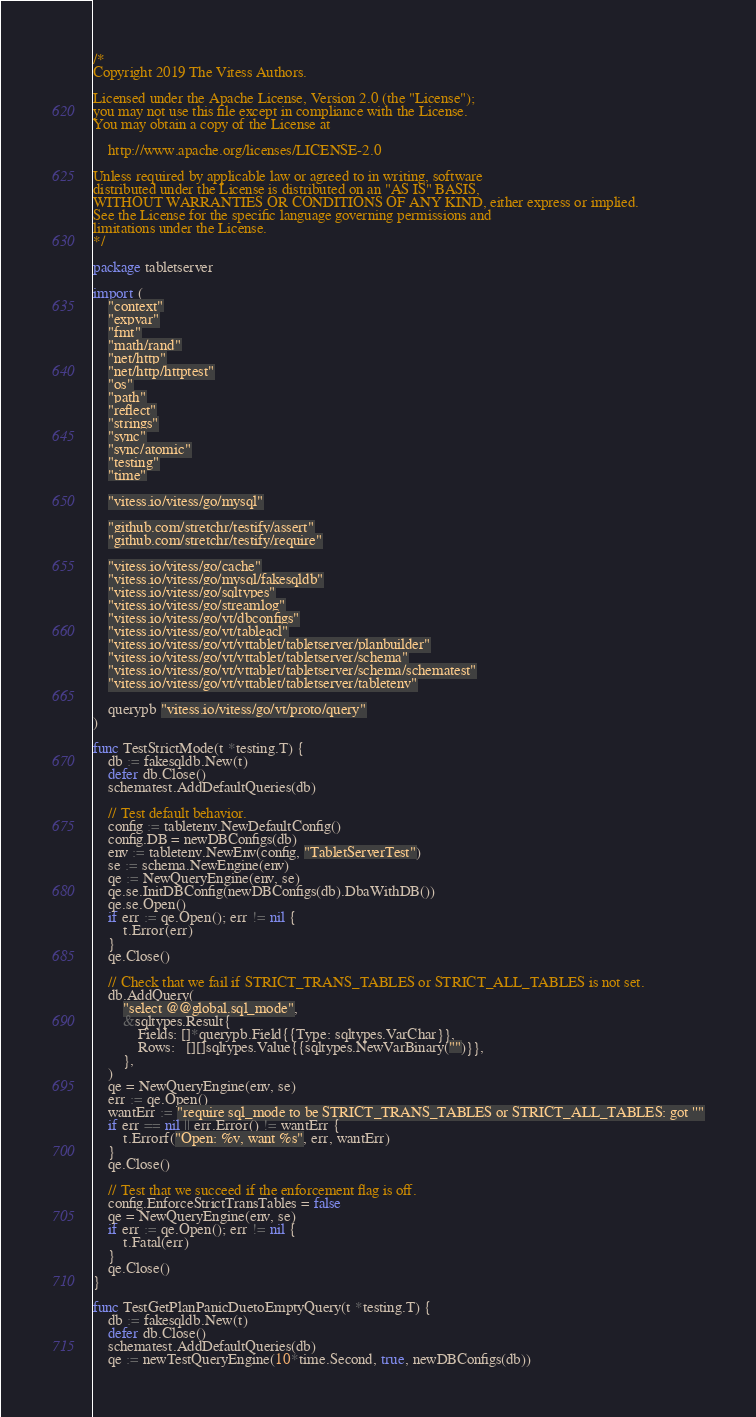<code> <loc_0><loc_0><loc_500><loc_500><_Go_>/*
Copyright 2019 The Vitess Authors.

Licensed under the Apache License, Version 2.0 (the "License");
you may not use this file except in compliance with the License.
You may obtain a copy of the License at

    http://www.apache.org/licenses/LICENSE-2.0

Unless required by applicable law or agreed to in writing, software
distributed under the License is distributed on an "AS IS" BASIS,
WITHOUT WARRANTIES OR CONDITIONS OF ANY KIND, either express or implied.
See the License for the specific language governing permissions and
limitations under the License.
*/

package tabletserver

import (
	"context"
	"expvar"
	"fmt"
	"math/rand"
	"net/http"
	"net/http/httptest"
	"os"
	"path"
	"reflect"
	"strings"
	"sync"
	"sync/atomic"
	"testing"
	"time"

	"vitess.io/vitess/go/mysql"

	"github.com/stretchr/testify/assert"
	"github.com/stretchr/testify/require"

	"vitess.io/vitess/go/cache"
	"vitess.io/vitess/go/mysql/fakesqldb"
	"vitess.io/vitess/go/sqltypes"
	"vitess.io/vitess/go/streamlog"
	"vitess.io/vitess/go/vt/dbconfigs"
	"vitess.io/vitess/go/vt/tableacl"
	"vitess.io/vitess/go/vt/vttablet/tabletserver/planbuilder"
	"vitess.io/vitess/go/vt/vttablet/tabletserver/schema"
	"vitess.io/vitess/go/vt/vttablet/tabletserver/schema/schematest"
	"vitess.io/vitess/go/vt/vttablet/tabletserver/tabletenv"

	querypb "vitess.io/vitess/go/vt/proto/query"
)

func TestStrictMode(t *testing.T) {
	db := fakesqldb.New(t)
	defer db.Close()
	schematest.AddDefaultQueries(db)

	// Test default behavior.
	config := tabletenv.NewDefaultConfig()
	config.DB = newDBConfigs(db)
	env := tabletenv.NewEnv(config, "TabletServerTest")
	se := schema.NewEngine(env)
	qe := NewQueryEngine(env, se)
	qe.se.InitDBConfig(newDBConfigs(db).DbaWithDB())
	qe.se.Open()
	if err := qe.Open(); err != nil {
		t.Error(err)
	}
	qe.Close()

	// Check that we fail if STRICT_TRANS_TABLES or STRICT_ALL_TABLES is not set.
	db.AddQuery(
		"select @@global.sql_mode",
		&sqltypes.Result{
			Fields: []*querypb.Field{{Type: sqltypes.VarChar}},
			Rows:   [][]sqltypes.Value{{sqltypes.NewVarBinary("")}},
		},
	)
	qe = NewQueryEngine(env, se)
	err := qe.Open()
	wantErr := "require sql_mode to be STRICT_TRANS_TABLES or STRICT_ALL_TABLES: got ''"
	if err == nil || err.Error() != wantErr {
		t.Errorf("Open: %v, want %s", err, wantErr)
	}
	qe.Close()

	// Test that we succeed if the enforcement flag is off.
	config.EnforceStrictTransTables = false
	qe = NewQueryEngine(env, se)
	if err := qe.Open(); err != nil {
		t.Fatal(err)
	}
	qe.Close()
}

func TestGetPlanPanicDuetoEmptyQuery(t *testing.T) {
	db := fakesqldb.New(t)
	defer db.Close()
	schematest.AddDefaultQueries(db)
	qe := newTestQueryEngine(10*time.Second, true, newDBConfigs(db))</code> 